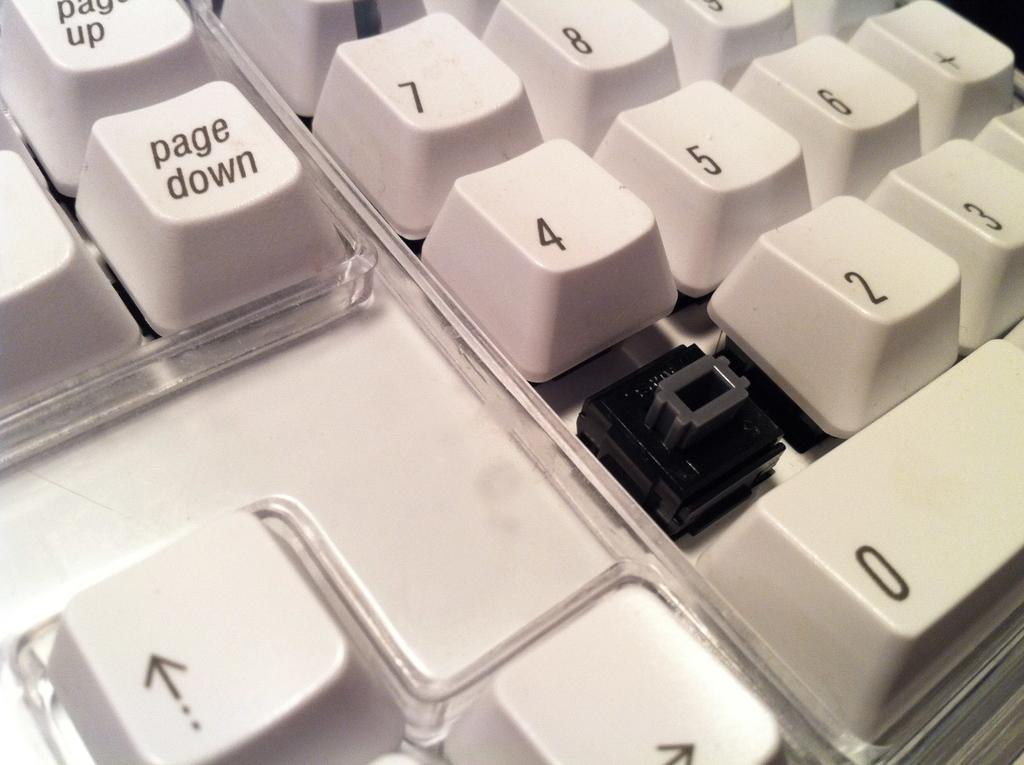<image>
Summarize the visual content of the image. A white plastic keyboard missing the one key and showing the page down key clearly. 